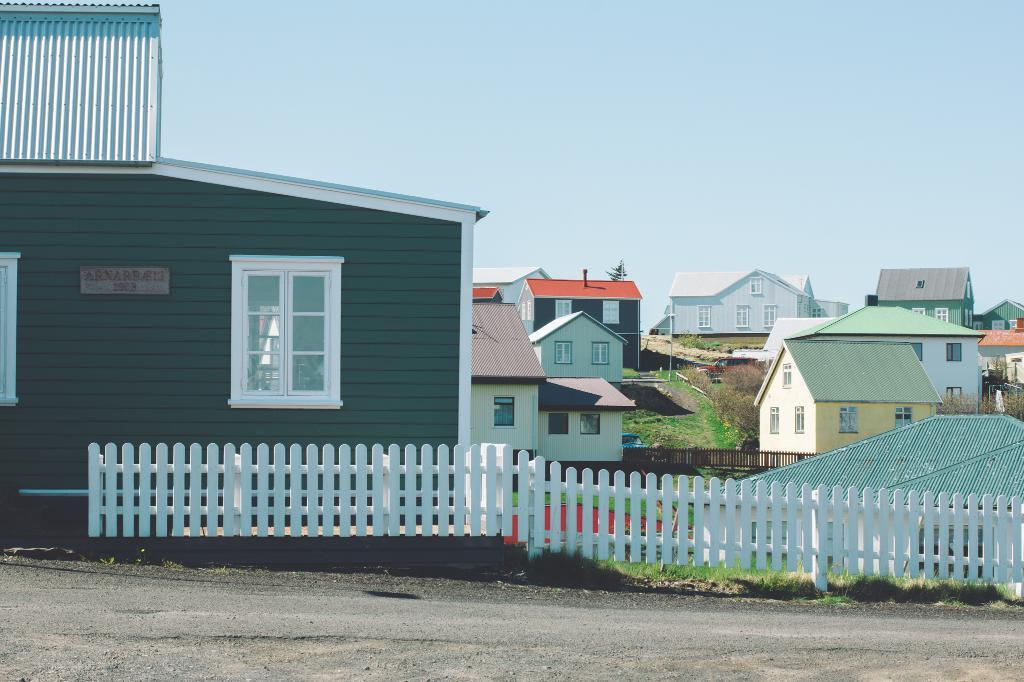What type of structures can be seen in the image? There are many houses in the image. What is visible at the top of the image? The sky is clear at the top of the image. What type of terrain is present between the houses? There is a grassy land between the houses. What type of collar is being worn by the copper statue during the feast in the image? There is no copper statue or feast present in the image; it features many houses and a clear sky. 